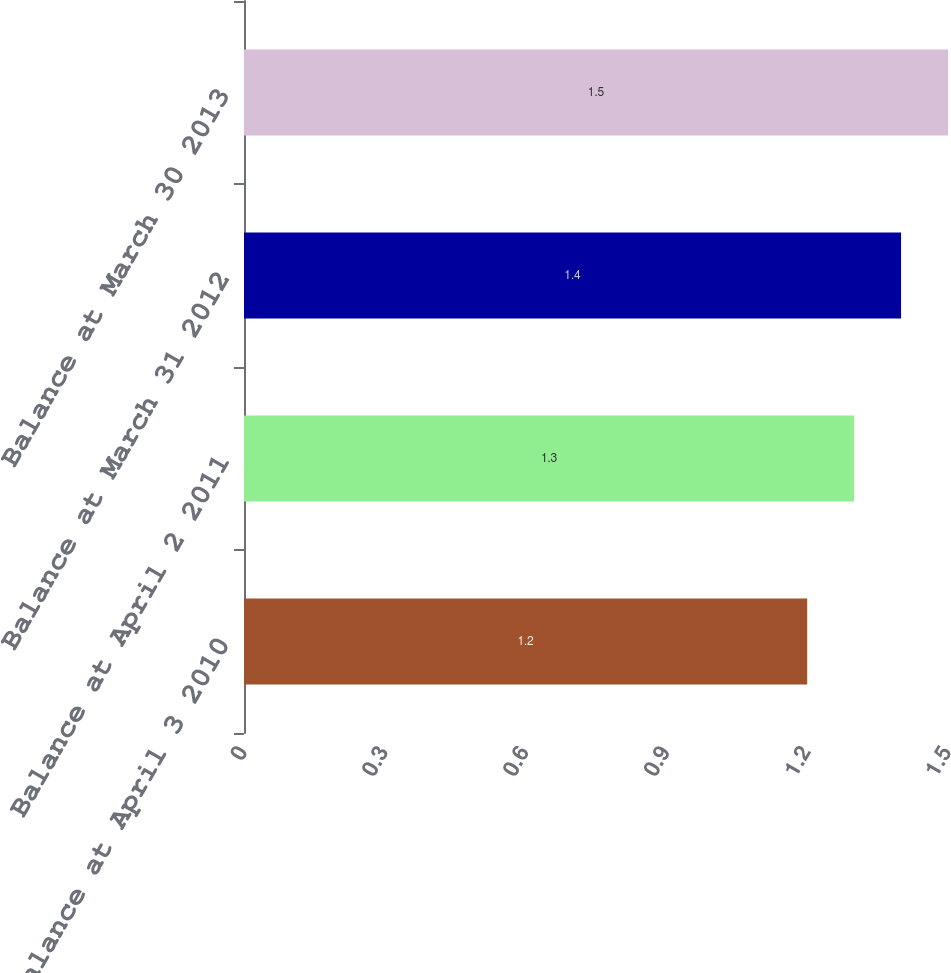Convert chart to OTSL. <chart><loc_0><loc_0><loc_500><loc_500><bar_chart><fcel>Balance at April 3 2010<fcel>Balance at April 2 2011<fcel>Balance at March 31 2012<fcel>Balance at March 30 2013<nl><fcel>1.2<fcel>1.3<fcel>1.4<fcel>1.5<nl></chart> 